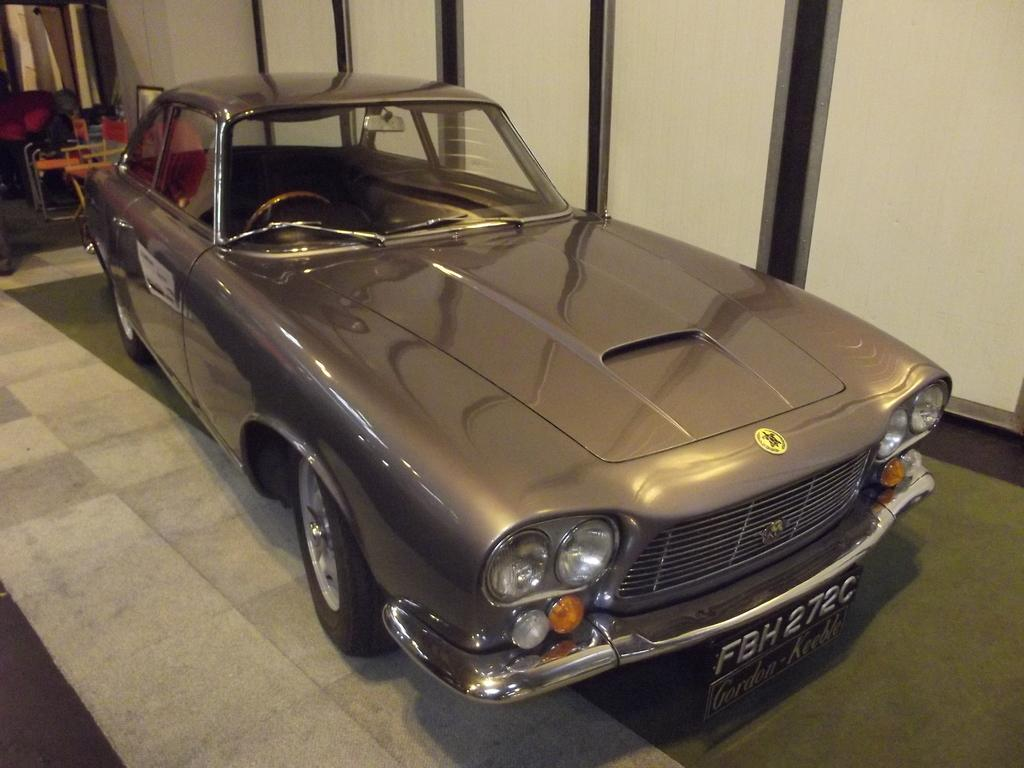What type of vehicle is in the image? There is a grey car in the image. Where is the car located in relation to other objects? The car is parked near a wooden partition. What furniture can be seen in the top left corner of the image? There is a table and chairs in the top left corner of the image. What other objects are visible in the top left corner of the image? There are other objects visible in the top left corner of the image. What type of guide is present in the image to help the car on its journey? There is no guide present in the image, and the car is parked, not on a journey. 